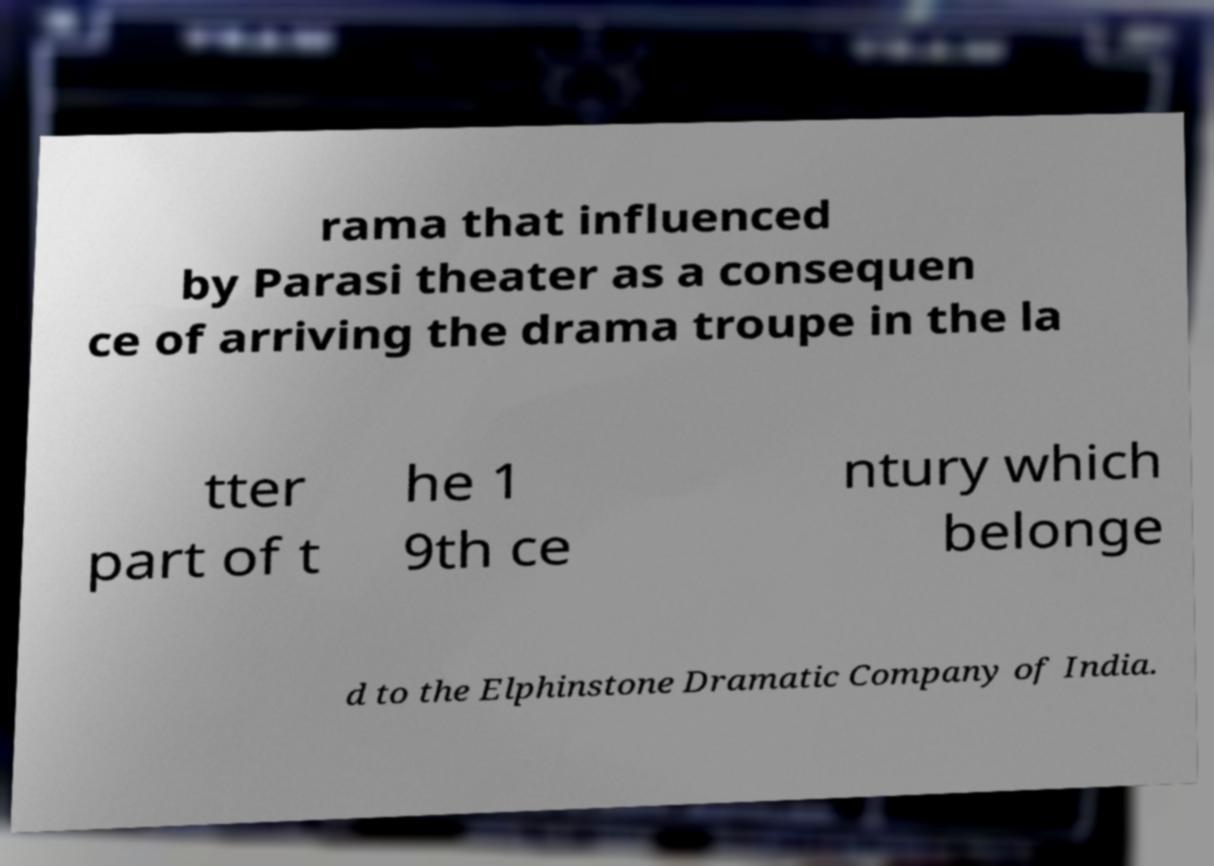What messages or text are displayed in this image? I need them in a readable, typed format. rama that influenced by Parasi theater as a consequen ce of arriving the drama troupe in the la tter part of t he 1 9th ce ntury which belonge d to the Elphinstone Dramatic Company of India. 